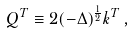<formula> <loc_0><loc_0><loc_500><loc_500>Q ^ { T } \equiv 2 ( - \Delta ) ^ { \frac { 1 } 2 } k ^ { T } \, ,</formula> 